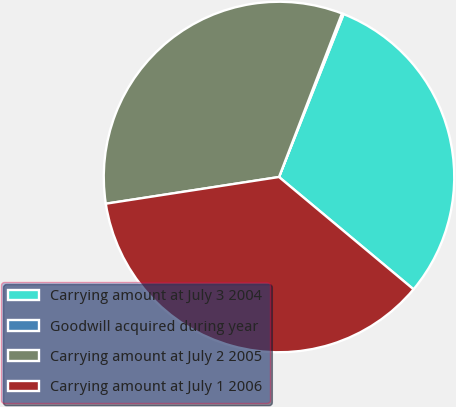Convert chart. <chart><loc_0><loc_0><loc_500><loc_500><pie_chart><fcel>Carrying amount at July 3 2004<fcel>Goodwill acquired during year<fcel>Carrying amount at July 2 2005<fcel>Carrying amount at July 1 2006<nl><fcel>30.06%<fcel>0.16%<fcel>33.28%<fcel>36.49%<nl></chart> 